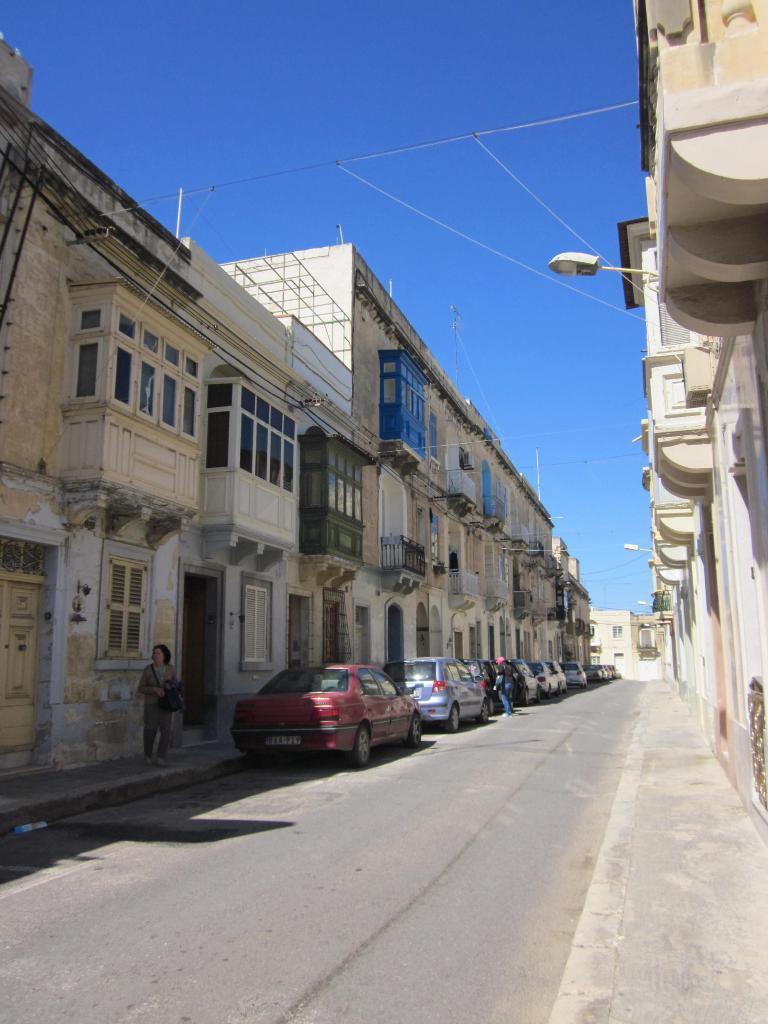In one or two sentences, can you explain what this image depicts? In this image there are buildings and we can see cars on the road. There are people. In the background there is sky. 